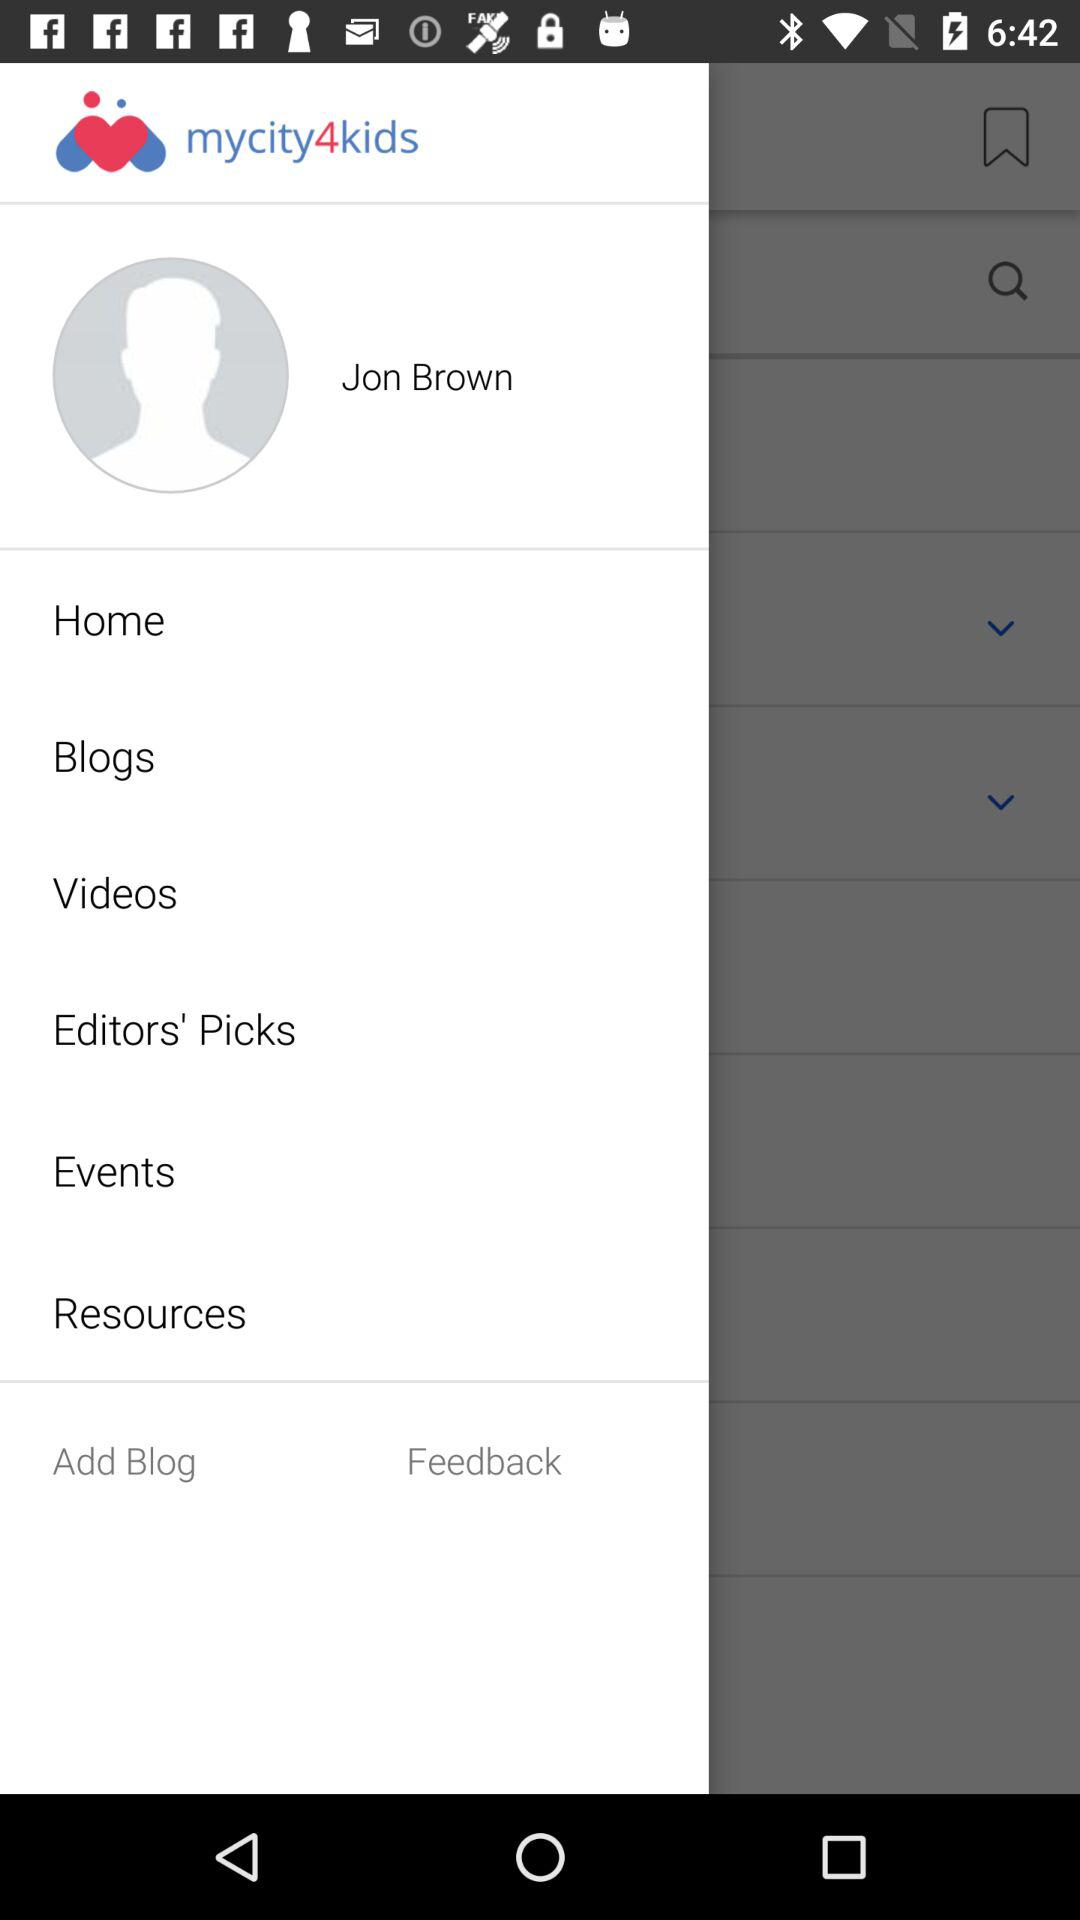What is the name of the application? The name of the application is "mycity4kids". 